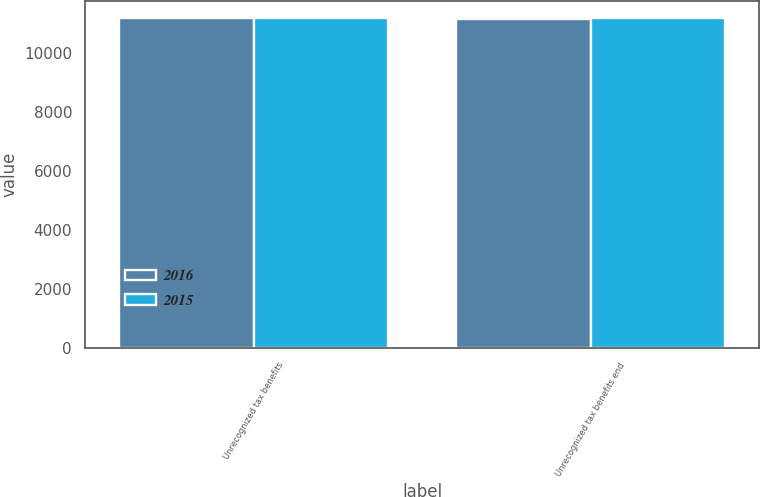Convert chart to OTSL. <chart><loc_0><loc_0><loc_500><loc_500><stacked_bar_chart><ecel><fcel>Unrecognized tax benefits<fcel>Unrecognized tax benefits end<nl><fcel>2016<fcel>11174<fcel>11144<nl><fcel>2015<fcel>11174<fcel>11174<nl></chart> 